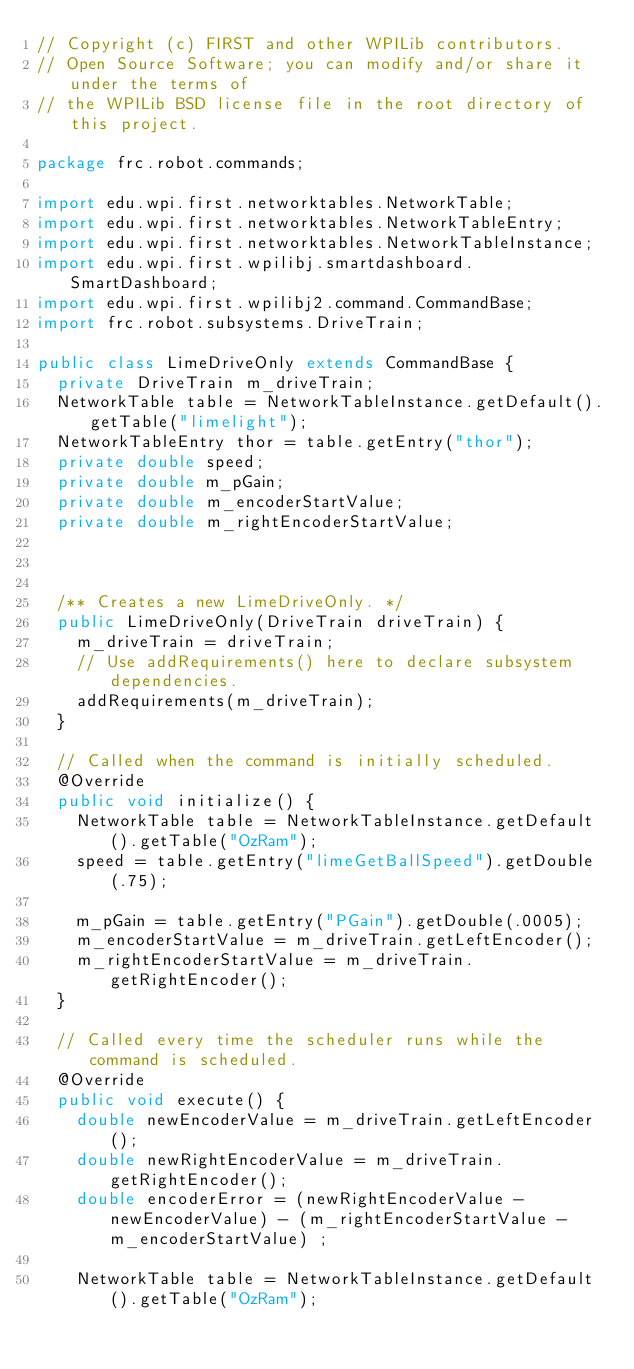<code> <loc_0><loc_0><loc_500><loc_500><_Java_>// Copyright (c) FIRST and other WPILib contributors.
// Open Source Software; you can modify and/or share it under the terms of
// the WPILib BSD license file in the root directory of this project.

package frc.robot.commands;

import edu.wpi.first.networktables.NetworkTable;
import edu.wpi.first.networktables.NetworkTableEntry;
import edu.wpi.first.networktables.NetworkTableInstance;
import edu.wpi.first.wpilibj.smartdashboard.SmartDashboard;
import edu.wpi.first.wpilibj2.command.CommandBase;
import frc.robot.subsystems.DriveTrain;

public class LimeDriveOnly extends CommandBase {
  private DriveTrain m_driveTrain;
  NetworkTable table = NetworkTableInstance.getDefault().getTable("limelight");
  NetworkTableEntry thor = table.getEntry("thor");
  private double speed;
  private double m_pGain;
  private double m_encoderStartValue;
  private double m_rightEncoderStartValue;


  
  /** Creates a new LimeDriveOnly. */
  public LimeDriveOnly(DriveTrain driveTrain) {
    m_driveTrain = driveTrain;
    // Use addRequirements() here to declare subsystem dependencies.
    addRequirements(m_driveTrain);
  }

  // Called when the command is initially scheduled.
  @Override
  public void initialize() {
    NetworkTable table = NetworkTableInstance.getDefault().getTable("OzRam");
    speed = table.getEntry("limeGetBallSpeed").getDouble(.75);

    m_pGain = table.getEntry("PGain").getDouble(.0005);
    m_encoderStartValue = m_driveTrain.getLeftEncoder();
    m_rightEncoderStartValue = m_driveTrain.getRightEncoder();
  }

  // Called every time the scheduler runs while the command is scheduled.
  @Override
  public void execute() {
    double newEncoderValue = m_driveTrain.getLeftEncoder();
    double newRightEncoderValue = m_driveTrain.getRightEncoder();
    double encoderError = (newRightEncoderValue - newEncoderValue) - (m_rightEncoderStartValue - m_encoderStartValue) ;
  
    NetworkTable table = NetworkTableInstance.getDefault().getTable("OzRam");</code> 